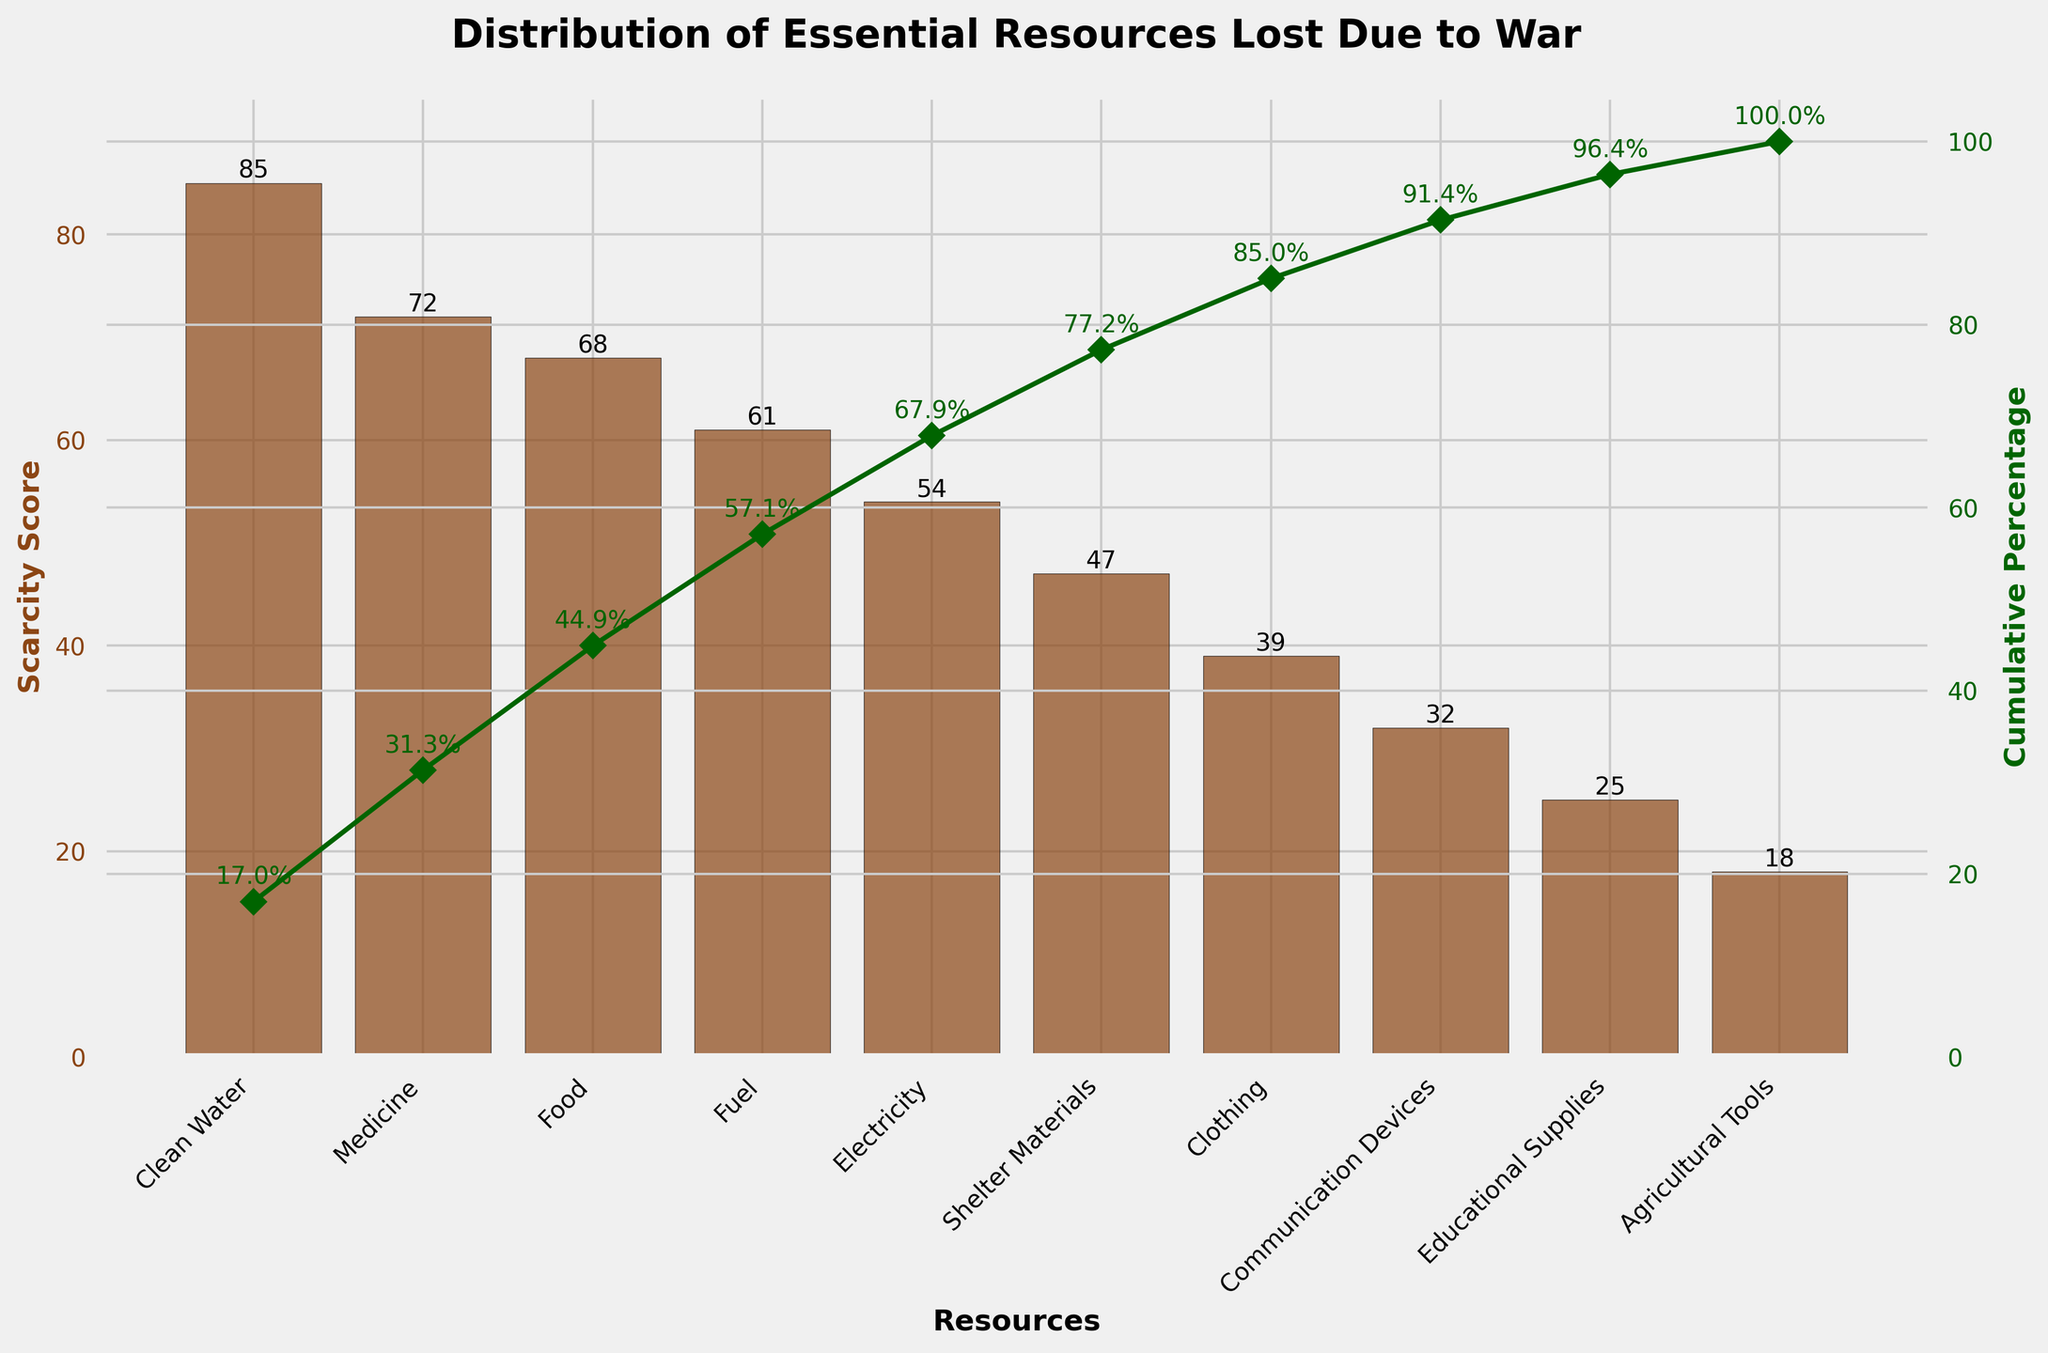What is the most scarce resource lost due to war? The most scarce resource can be identified by looking at the highest bar on the plot. The highest bar represents "Clean Water" with a scarcity score of 85.
Answer: Clean Water What resources have a scarcity score above 60? By observing the bar heights and the labels on the x-axis, the resources with a scarcity score above 60 are "Clean Water," "Medicine," "Food," and "Fuel."
Answer: Clean Water, Medicine, Food, Fuel What is the total cumulative percentage of Clean Water, Medicine, and Food? The cumulative percentage of Clean Water is about 22.0%, adding Medicine’s cumulative percentage (~40.7%) and Food’s (~57.4%) results in approximately 57.4%.
Answer: 57.4% Which resource is less scarce: Shelter Materials or Communication Devices? By comparing the bar heights of "Shelter Materials" and "Communication Devices," it is clear that "Shelter Materials" has a score of 47 and "Communication Devices" has a score of 32.
Answer: Communication Devices What is the cumulative percentage for Fuel? The cumulative percentage line for Fuel is around 74.1%, as marked on the line plot.
Answer: 74.1% How many resources have a scarcity score below 50? By identifying the bars that have heights below 50, the resources are "Shelter Materials," "Clothing," "Communication Devices," "Educational Supplies," and "Agricultural Tools." So, there are 5 resources.
Answer: 5 Which resource contributes the least to the cumulative scarcity percentage? The least contribution can be identified by the shortest bar, which represents "Agricultural Tools."
Answer: Agricultural Tools What is the difference in scarcity scores between Clean Water and Electricity? The scarcity score for Clean Water is 85, and for Electricity, it is 54. The difference is 85 - 54 = 31.
Answer: 31 Which resource's scarcity score is closest to the median score of all the resources listed? To find the median, list all scarcity scores in ascending order: [18, 25, 32, 39, 47, 54, 61, 68, 72, 85]. The median score (5th and 6th values) is between 47 and 54, closer to the 5th value, which is "Shelter Materials."
Answer: Shelter Materials 